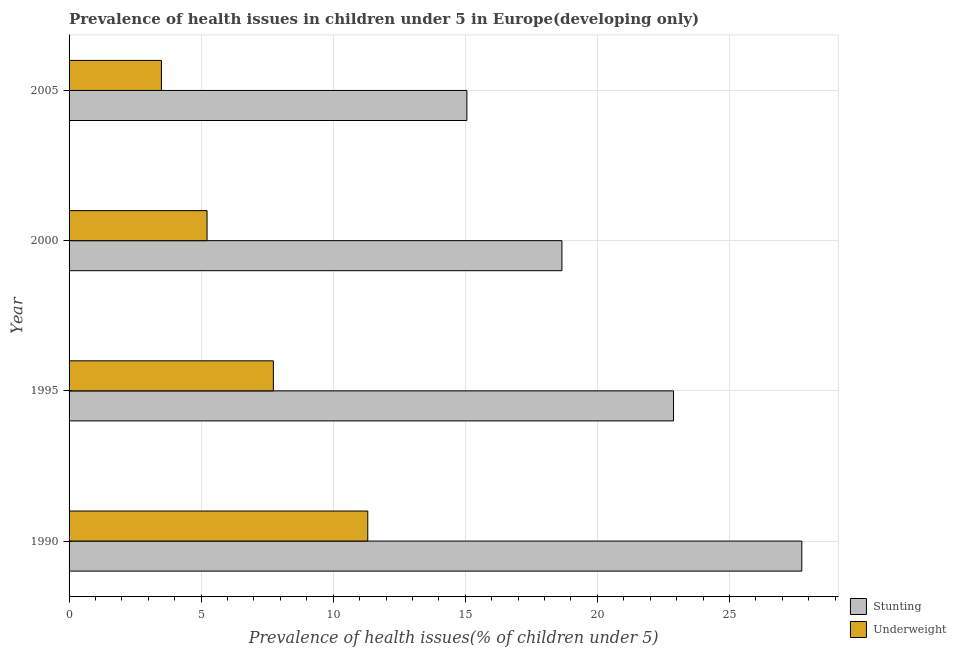How many different coloured bars are there?
Your answer should be compact. 2. How many groups of bars are there?
Keep it short and to the point. 4. Are the number of bars on each tick of the Y-axis equal?
Ensure brevity in your answer.  Yes. How many bars are there on the 4th tick from the bottom?
Offer a terse response. 2. What is the percentage of stunted children in 2000?
Your response must be concise. 18.66. Across all years, what is the maximum percentage of underweight children?
Provide a succinct answer. 11.31. Across all years, what is the minimum percentage of underweight children?
Your response must be concise. 3.5. What is the total percentage of stunted children in the graph?
Give a very brief answer. 84.33. What is the difference between the percentage of underweight children in 1995 and that in 2000?
Make the answer very short. 2.51. What is the difference between the percentage of stunted children in 1995 and the percentage of underweight children in 1990?
Make the answer very short. 11.57. What is the average percentage of stunted children per year?
Keep it short and to the point. 21.08. In the year 1995, what is the difference between the percentage of stunted children and percentage of underweight children?
Provide a succinct answer. 15.15. In how many years, is the percentage of stunted children greater than 6 %?
Your answer should be very brief. 4. What is the ratio of the percentage of underweight children in 1990 to that in 1995?
Offer a very short reply. 1.46. Is the percentage of stunted children in 1990 less than that in 1995?
Provide a short and direct response. No. Is the difference between the percentage of stunted children in 1995 and 2000 greater than the difference between the percentage of underweight children in 1995 and 2000?
Give a very brief answer. Yes. What is the difference between the highest and the second highest percentage of stunted children?
Give a very brief answer. 4.86. What is the difference between the highest and the lowest percentage of stunted children?
Offer a very short reply. 12.68. What does the 2nd bar from the top in 1995 represents?
Your answer should be compact. Stunting. What does the 2nd bar from the bottom in 2005 represents?
Keep it short and to the point. Underweight. What is the difference between two consecutive major ticks on the X-axis?
Your response must be concise. 5. Does the graph contain any zero values?
Make the answer very short. No. What is the title of the graph?
Keep it short and to the point. Prevalence of health issues in children under 5 in Europe(developing only). Does "Underweight" appear as one of the legend labels in the graph?
Your response must be concise. Yes. What is the label or title of the X-axis?
Make the answer very short. Prevalence of health issues(% of children under 5). What is the Prevalence of health issues(% of children under 5) of Stunting in 1990?
Your answer should be compact. 27.74. What is the Prevalence of health issues(% of children under 5) of Underweight in 1990?
Offer a very short reply. 11.31. What is the Prevalence of health issues(% of children under 5) in Stunting in 1995?
Provide a short and direct response. 22.88. What is the Prevalence of health issues(% of children under 5) in Underweight in 1995?
Offer a terse response. 7.73. What is the Prevalence of health issues(% of children under 5) of Stunting in 2000?
Provide a succinct answer. 18.66. What is the Prevalence of health issues(% of children under 5) in Underweight in 2000?
Your answer should be compact. 5.22. What is the Prevalence of health issues(% of children under 5) in Stunting in 2005?
Your answer should be compact. 15.06. What is the Prevalence of health issues(% of children under 5) in Underweight in 2005?
Give a very brief answer. 3.5. Across all years, what is the maximum Prevalence of health issues(% of children under 5) in Stunting?
Your answer should be very brief. 27.74. Across all years, what is the maximum Prevalence of health issues(% of children under 5) of Underweight?
Make the answer very short. 11.31. Across all years, what is the minimum Prevalence of health issues(% of children under 5) in Stunting?
Provide a short and direct response. 15.06. Across all years, what is the minimum Prevalence of health issues(% of children under 5) in Underweight?
Your answer should be very brief. 3.5. What is the total Prevalence of health issues(% of children under 5) of Stunting in the graph?
Ensure brevity in your answer.  84.33. What is the total Prevalence of health issues(% of children under 5) in Underweight in the graph?
Keep it short and to the point. 27.76. What is the difference between the Prevalence of health issues(% of children under 5) of Stunting in 1990 and that in 1995?
Keep it short and to the point. 4.86. What is the difference between the Prevalence of health issues(% of children under 5) of Underweight in 1990 and that in 1995?
Make the answer very short. 3.57. What is the difference between the Prevalence of health issues(% of children under 5) of Stunting in 1990 and that in 2000?
Offer a terse response. 9.08. What is the difference between the Prevalence of health issues(% of children under 5) in Underweight in 1990 and that in 2000?
Your answer should be very brief. 6.08. What is the difference between the Prevalence of health issues(% of children under 5) of Stunting in 1990 and that in 2005?
Offer a very short reply. 12.68. What is the difference between the Prevalence of health issues(% of children under 5) in Underweight in 1990 and that in 2005?
Give a very brief answer. 7.81. What is the difference between the Prevalence of health issues(% of children under 5) of Stunting in 1995 and that in 2000?
Your answer should be compact. 4.22. What is the difference between the Prevalence of health issues(% of children under 5) in Underweight in 1995 and that in 2000?
Make the answer very short. 2.51. What is the difference between the Prevalence of health issues(% of children under 5) of Stunting in 1995 and that in 2005?
Your answer should be very brief. 7.82. What is the difference between the Prevalence of health issues(% of children under 5) in Underweight in 1995 and that in 2005?
Provide a short and direct response. 4.24. What is the difference between the Prevalence of health issues(% of children under 5) in Stunting in 2000 and that in 2005?
Your answer should be compact. 3.6. What is the difference between the Prevalence of health issues(% of children under 5) of Underweight in 2000 and that in 2005?
Give a very brief answer. 1.73. What is the difference between the Prevalence of health issues(% of children under 5) of Stunting in 1990 and the Prevalence of health issues(% of children under 5) of Underweight in 1995?
Provide a short and direct response. 20. What is the difference between the Prevalence of health issues(% of children under 5) in Stunting in 1990 and the Prevalence of health issues(% of children under 5) in Underweight in 2000?
Make the answer very short. 22.51. What is the difference between the Prevalence of health issues(% of children under 5) of Stunting in 1990 and the Prevalence of health issues(% of children under 5) of Underweight in 2005?
Give a very brief answer. 24.24. What is the difference between the Prevalence of health issues(% of children under 5) in Stunting in 1995 and the Prevalence of health issues(% of children under 5) in Underweight in 2000?
Your answer should be very brief. 17.66. What is the difference between the Prevalence of health issues(% of children under 5) in Stunting in 1995 and the Prevalence of health issues(% of children under 5) in Underweight in 2005?
Your answer should be compact. 19.39. What is the difference between the Prevalence of health issues(% of children under 5) in Stunting in 2000 and the Prevalence of health issues(% of children under 5) in Underweight in 2005?
Provide a short and direct response. 15.16. What is the average Prevalence of health issues(% of children under 5) of Stunting per year?
Provide a short and direct response. 21.08. What is the average Prevalence of health issues(% of children under 5) in Underweight per year?
Make the answer very short. 6.94. In the year 1990, what is the difference between the Prevalence of health issues(% of children under 5) of Stunting and Prevalence of health issues(% of children under 5) of Underweight?
Provide a short and direct response. 16.43. In the year 1995, what is the difference between the Prevalence of health issues(% of children under 5) in Stunting and Prevalence of health issues(% of children under 5) in Underweight?
Ensure brevity in your answer.  15.15. In the year 2000, what is the difference between the Prevalence of health issues(% of children under 5) of Stunting and Prevalence of health issues(% of children under 5) of Underweight?
Make the answer very short. 13.43. In the year 2005, what is the difference between the Prevalence of health issues(% of children under 5) in Stunting and Prevalence of health issues(% of children under 5) in Underweight?
Give a very brief answer. 11.56. What is the ratio of the Prevalence of health issues(% of children under 5) in Stunting in 1990 to that in 1995?
Keep it short and to the point. 1.21. What is the ratio of the Prevalence of health issues(% of children under 5) in Underweight in 1990 to that in 1995?
Your answer should be very brief. 1.46. What is the ratio of the Prevalence of health issues(% of children under 5) in Stunting in 1990 to that in 2000?
Provide a succinct answer. 1.49. What is the ratio of the Prevalence of health issues(% of children under 5) of Underweight in 1990 to that in 2000?
Your response must be concise. 2.17. What is the ratio of the Prevalence of health issues(% of children under 5) of Stunting in 1990 to that in 2005?
Provide a short and direct response. 1.84. What is the ratio of the Prevalence of health issues(% of children under 5) of Underweight in 1990 to that in 2005?
Your response must be concise. 3.23. What is the ratio of the Prevalence of health issues(% of children under 5) in Stunting in 1995 to that in 2000?
Make the answer very short. 1.23. What is the ratio of the Prevalence of health issues(% of children under 5) of Underweight in 1995 to that in 2000?
Your answer should be very brief. 1.48. What is the ratio of the Prevalence of health issues(% of children under 5) in Stunting in 1995 to that in 2005?
Your answer should be very brief. 1.52. What is the ratio of the Prevalence of health issues(% of children under 5) in Underweight in 1995 to that in 2005?
Ensure brevity in your answer.  2.21. What is the ratio of the Prevalence of health issues(% of children under 5) of Stunting in 2000 to that in 2005?
Provide a short and direct response. 1.24. What is the ratio of the Prevalence of health issues(% of children under 5) of Underweight in 2000 to that in 2005?
Provide a short and direct response. 1.49. What is the difference between the highest and the second highest Prevalence of health issues(% of children under 5) in Stunting?
Give a very brief answer. 4.86. What is the difference between the highest and the second highest Prevalence of health issues(% of children under 5) in Underweight?
Keep it short and to the point. 3.57. What is the difference between the highest and the lowest Prevalence of health issues(% of children under 5) in Stunting?
Your answer should be very brief. 12.68. What is the difference between the highest and the lowest Prevalence of health issues(% of children under 5) of Underweight?
Keep it short and to the point. 7.81. 